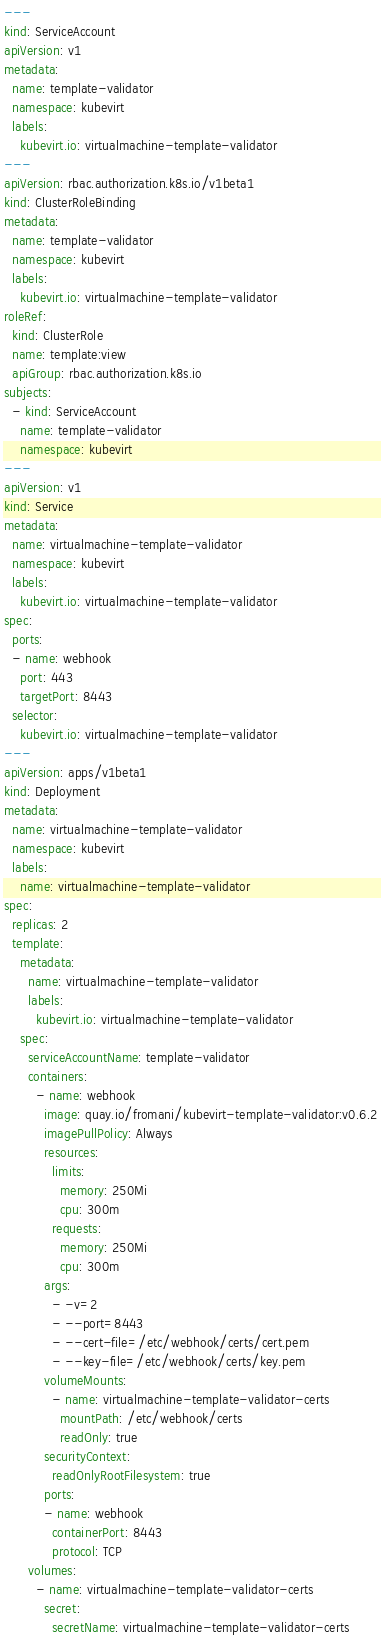<code> <loc_0><loc_0><loc_500><loc_500><_YAML_>---
kind: ServiceAccount
apiVersion: v1
metadata:
  name: template-validator
  namespace: kubevirt
  labels:
    kubevirt.io: virtualmachine-template-validator
---
apiVersion: rbac.authorization.k8s.io/v1beta1
kind: ClusterRoleBinding
metadata:
  name: template-validator
  namespace: kubevirt
  labels:
    kubevirt.io: virtualmachine-template-validator
roleRef:
  kind: ClusterRole
  name: template:view
  apiGroup: rbac.authorization.k8s.io
subjects:
  - kind: ServiceAccount
    name: template-validator
    namespace: kubevirt
---
apiVersion: v1
kind: Service
metadata:
  name: virtualmachine-template-validator
  namespace: kubevirt
  labels:
    kubevirt.io: virtualmachine-template-validator
spec:
  ports:
  - name: webhook
    port: 443
    targetPort: 8443
  selector:
    kubevirt.io: virtualmachine-template-validator
---
apiVersion: apps/v1beta1
kind: Deployment
metadata:
  name: virtualmachine-template-validator
  namespace: kubevirt
  labels:
    name: virtualmachine-template-validator
spec:
  replicas: 2
  template:
    metadata:
      name: virtualmachine-template-validator 
      labels:
        kubevirt.io: virtualmachine-template-validator
    spec:
      serviceAccountName: template-validator
      containers:
        - name: webhook
          image: quay.io/fromani/kubevirt-template-validator:v0.6.2
          imagePullPolicy: Always
          resources:
            limits:
              memory: 250Mi
              cpu: 300m
            requests:
              memory: 250Mi
              cpu: 300m
          args:
            - -v=2
            - --port=8443
            - --cert-file=/etc/webhook/certs/cert.pem
            - --key-file=/etc/webhook/certs/key.pem
          volumeMounts:
            - name: virtualmachine-template-validator-certs
              mountPath: /etc/webhook/certs
              readOnly: true
          securityContext:
            readOnlyRootFilesystem: true
          ports:
          - name: webhook
            containerPort: 8443
            protocol: TCP
      volumes:
        - name: virtualmachine-template-validator-certs
          secret:
            secretName: virtualmachine-template-validator-certs

</code> 